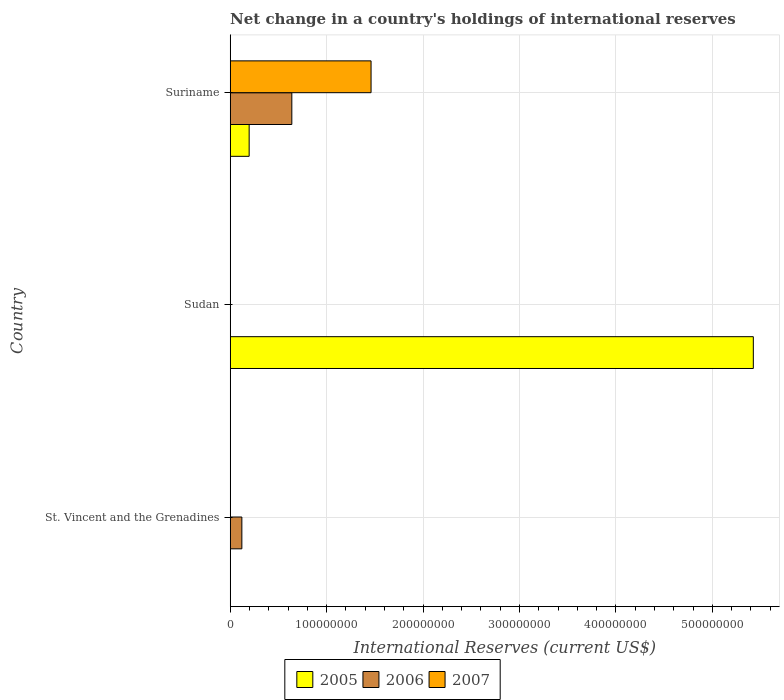How many different coloured bars are there?
Your answer should be very brief. 3. Are the number of bars per tick equal to the number of legend labels?
Your answer should be compact. No. How many bars are there on the 1st tick from the top?
Offer a very short reply. 3. How many bars are there on the 2nd tick from the bottom?
Provide a short and direct response. 1. What is the label of the 2nd group of bars from the top?
Offer a terse response. Sudan. In how many cases, is the number of bars for a given country not equal to the number of legend labels?
Ensure brevity in your answer.  2. What is the international reserves in 2007 in Sudan?
Your response must be concise. 0. Across all countries, what is the maximum international reserves in 2006?
Your answer should be very brief. 6.39e+07. Across all countries, what is the minimum international reserves in 2006?
Give a very brief answer. 0. In which country was the international reserves in 2006 maximum?
Make the answer very short. Suriname. What is the total international reserves in 2005 in the graph?
Your response must be concise. 5.62e+08. What is the difference between the international reserves in 2006 in St. Vincent and the Grenadines and that in Suriname?
Give a very brief answer. -5.18e+07. What is the difference between the international reserves in 2005 in Sudan and the international reserves in 2006 in St. Vincent and the Grenadines?
Your answer should be compact. 5.30e+08. What is the average international reserves in 2006 per country?
Ensure brevity in your answer.  2.53e+07. What is the difference between the international reserves in 2006 and international reserves in 2005 in Suriname?
Your answer should be compact. 4.42e+07. In how many countries, is the international reserves in 2005 greater than 120000000 US$?
Make the answer very short. 1. What is the ratio of the international reserves in 2006 in St. Vincent and the Grenadines to that in Suriname?
Your answer should be very brief. 0.19. What is the difference between the highest and the lowest international reserves in 2006?
Make the answer very short. 6.39e+07. In how many countries, is the international reserves in 2006 greater than the average international reserves in 2006 taken over all countries?
Your answer should be compact. 1. Is it the case that in every country, the sum of the international reserves in 2005 and international reserves in 2007 is greater than the international reserves in 2006?
Your response must be concise. No. Are all the bars in the graph horizontal?
Provide a short and direct response. Yes. How many countries are there in the graph?
Provide a short and direct response. 3. What is the title of the graph?
Give a very brief answer. Net change in a country's holdings of international reserves. Does "1991" appear as one of the legend labels in the graph?
Keep it short and to the point. No. What is the label or title of the X-axis?
Offer a very short reply. International Reserves (current US$). What is the label or title of the Y-axis?
Your answer should be very brief. Country. What is the International Reserves (current US$) in 2005 in St. Vincent and the Grenadines?
Make the answer very short. 0. What is the International Reserves (current US$) in 2006 in St. Vincent and the Grenadines?
Ensure brevity in your answer.  1.21e+07. What is the International Reserves (current US$) in 2005 in Sudan?
Your answer should be compact. 5.42e+08. What is the International Reserves (current US$) in 2007 in Sudan?
Offer a very short reply. 0. What is the International Reserves (current US$) in 2005 in Suriname?
Make the answer very short. 1.97e+07. What is the International Reserves (current US$) in 2006 in Suriname?
Provide a succinct answer. 6.39e+07. What is the International Reserves (current US$) in 2007 in Suriname?
Offer a very short reply. 1.46e+08. Across all countries, what is the maximum International Reserves (current US$) in 2005?
Your response must be concise. 5.42e+08. Across all countries, what is the maximum International Reserves (current US$) in 2006?
Offer a terse response. 6.39e+07. Across all countries, what is the maximum International Reserves (current US$) in 2007?
Offer a terse response. 1.46e+08. Across all countries, what is the minimum International Reserves (current US$) in 2005?
Give a very brief answer. 0. What is the total International Reserves (current US$) of 2005 in the graph?
Make the answer very short. 5.62e+08. What is the total International Reserves (current US$) in 2006 in the graph?
Offer a very short reply. 7.60e+07. What is the total International Reserves (current US$) in 2007 in the graph?
Make the answer very short. 1.46e+08. What is the difference between the International Reserves (current US$) of 2006 in St. Vincent and the Grenadines and that in Suriname?
Provide a short and direct response. -5.18e+07. What is the difference between the International Reserves (current US$) in 2005 in Sudan and that in Suriname?
Ensure brevity in your answer.  5.23e+08. What is the difference between the International Reserves (current US$) in 2006 in St. Vincent and the Grenadines and the International Reserves (current US$) in 2007 in Suriname?
Ensure brevity in your answer.  -1.34e+08. What is the difference between the International Reserves (current US$) in 2005 in Sudan and the International Reserves (current US$) in 2006 in Suriname?
Ensure brevity in your answer.  4.79e+08. What is the difference between the International Reserves (current US$) of 2005 in Sudan and the International Reserves (current US$) of 2007 in Suriname?
Provide a succinct answer. 3.96e+08. What is the average International Reserves (current US$) of 2005 per country?
Provide a short and direct response. 1.87e+08. What is the average International Reserves (current US$) in 2006 per country?
Give a very brief answer. 2.53e+07. What is the average International Reserves (current US$) in 2007 per country?
Keep it short and to the point. 4.87e+07. What is the difference between the International Reserves (current US$) of 2005 and International Reserves (current US$) of 2006 in Suriname?
Ensure brevity in your answer.  -4.42e+07. What is the difference between the International Reserves (current US$) of 2005 and International Reserves (current US$) of 2007 in Suriname?
Ensure brevity in your answer.  -1.26e+08. What is the difference between the International Reserves (current US$) in 2006 and International Reserves (current US$) in 2007 in Suriname?
Your answer should be compact. -8.22e+07. What is the ratio of the International Reserves (current US$) in 2006 in St. Vincent and the Grenadines to that in Suriname?
Give a very brief answer. 0.19. What is the ratio of the International Reserves (current US$) of 2005 in Sudan to that in Suriname?
Make the answer very short. 27.57. What is the difference between the highest and the lowest International Reserves (current US$) of 2005?
Your answer should be compact. 5.42e+08. What is the difference between the highest and the lowest International Reserves (current US$) of 2006?
Make the answer very short. 6.39e+07. What is the difference between the highest and the lowest International Reserves (current US$) in 2007?
Ensure brevity in your answer.  1.46e+08. 